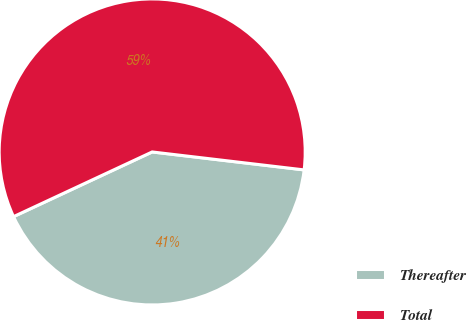Convert chart to OTSL. <chart><loc_0><loc_0><loc_500><loc_500><pie_chart><fcel>Thereafter<fcel>Total<nl><fcel>41.18%<fcel>58.82%<nl></chart> 